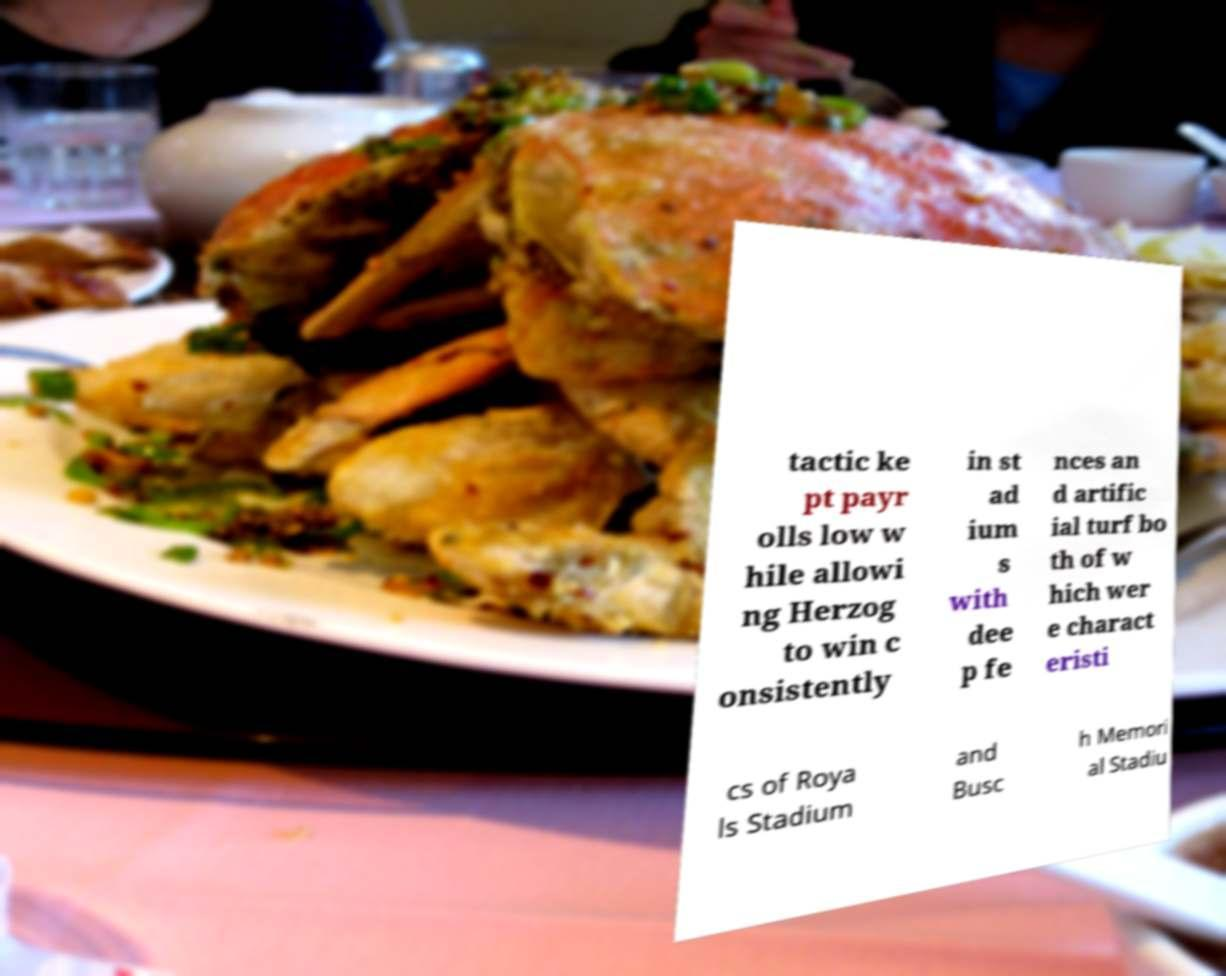Could you extract and type out the text from this image? tactic ke pt payr olls low w hile allowi ng Herzog to win c onsistently in st ad ium s with dee p fe nces an d artific ial turf bo th of w hich wer e charact eristi cs of Roya ls Stadium and Busc h Memori al Stadiu 